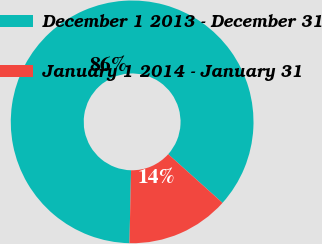Convert chart. <chart><loc_0><loc_0><loc_500><loc_500><pie_chart><fcel>December 1 2013 - December 31<fcel>January 1 2014 - January 31<nl><fcel>86.28%<fcel>13.72%<nl></chart> 